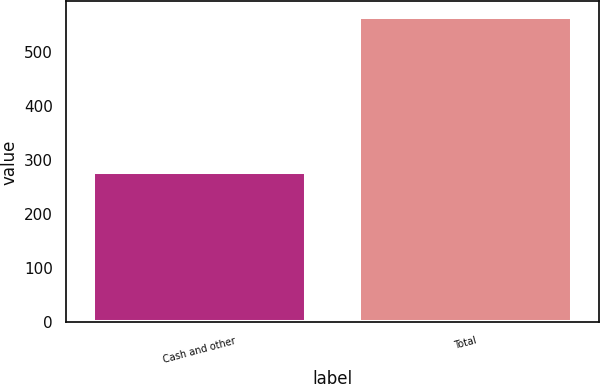Convert chart to OTSL. <chart><loc_0><loc_0><loc_500><loc_500><bar_chart><fcel>Cash and other<fcel>Total<nl><fcel>278.7<fcel>565.3<nl></chart> 